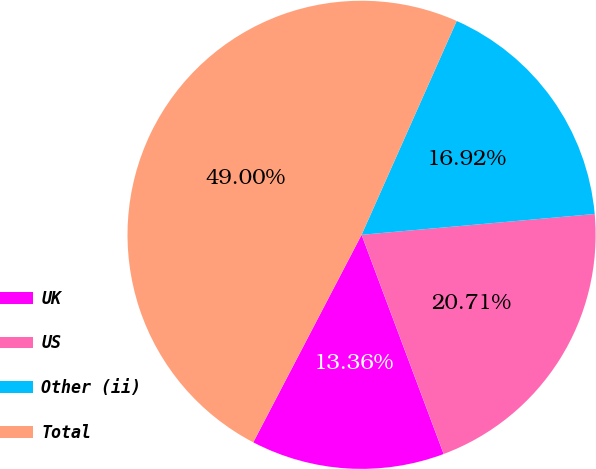<chart> <loc_0><loc_0><loc_500><loc_500><pie_chart><fcel>UK<fcel>US<fcel>Other (ii)<fcel>Total<nl><fcel>13.36%<fcel>20.71%<fcel>16.92%<fcel>49.0%<nl></chart> 